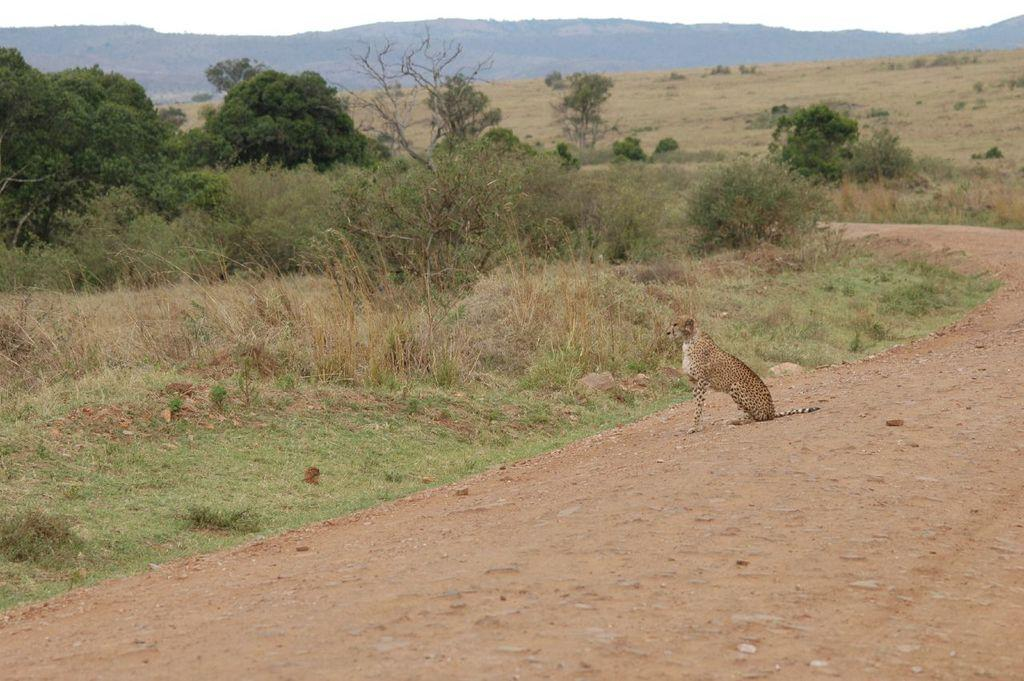What type of terrain is visible in the image? There is a muddy path and a grass surface in the image. What animal can be seen in the image? A cheetah is sitting in the image. What type of vegetation is present in the image? Plants and trees are visible in the image. What geographical features can be observed in the image? Hills are observable in the image. What part of the natural environment is visible in the image? The sky is visible in the image. How does the cheetah turn the force of gravity in the image? The cheetah does not turn the force of gravity in the image; it is simply sitting on the grass surface. What type of cub is playing with the cheetah in the image? There is no cub present in the image; only a cheetah is visible. 